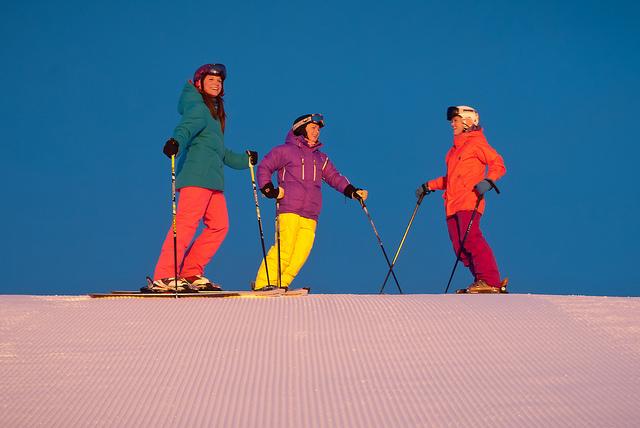Which girl has a purple parka?
Answer briefly. Middle. Has this trail recently been groomed?
Short answer required. Yes. What sport is shown?
Keep it brief. Skiing. Are there any clouds in the sky?
Quick response, please. No. 